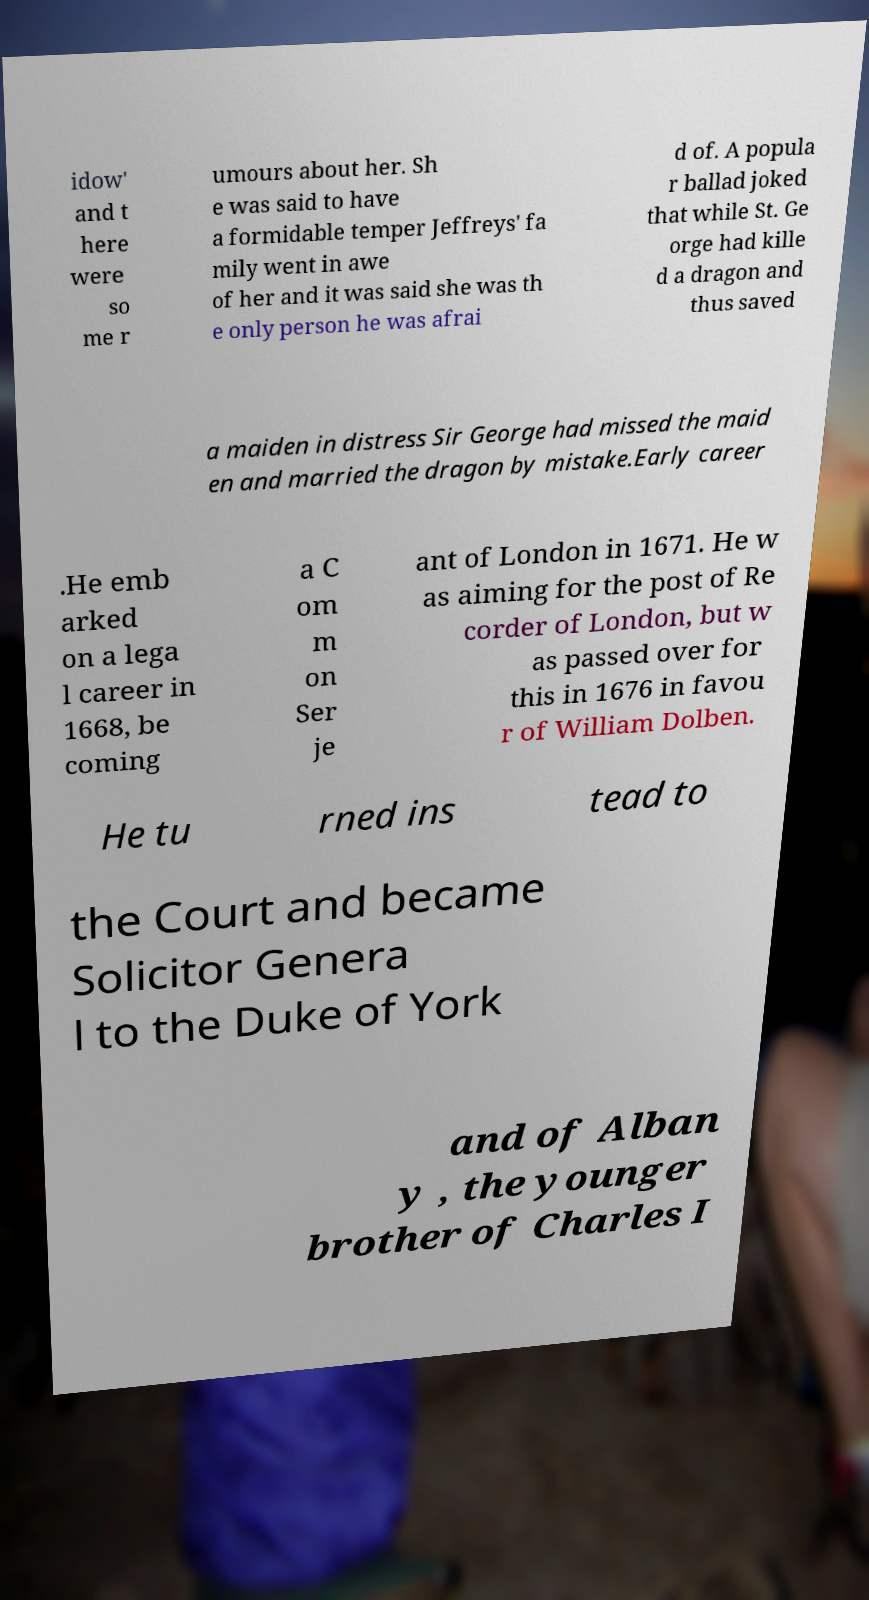I need the written content from this picture converted into text. Can you do that? idow' and t here were so me r umours about her. Sh e was said to have a formidable temper Jeffreys' fa mily went in awe of her and it was said she was th e only person he was afrai d of. A popula r ballad joked that while St. Ge orge had kille d a dragon and thus saved a maiden in distress Sir George had missed the maid en and married the dragon by mistake.Early career .He emb arked on a lega l career in 1668, be coming a C om m on Ser je ant of London in 1671. He w as aiming for the post of Re corder of London, but w as passed over for this in 1676 in favou r of William Dolben. He tu rned ins tead to the Court and became Solicitor Genera l to the Duke of York and of Alban y , the younger brother of Charles I 